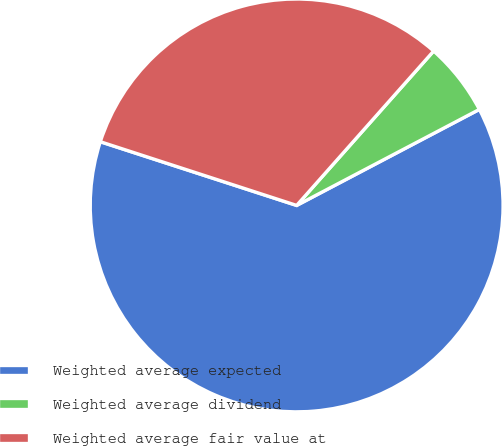<chart> <loc_0><loc_0><loc_500><loc_500><pie_chart><fcel>Weighted average expected<fcel>Weighted average dividend<fcel>Weighted average fair value at<nl><fcel>62.7%<fcel>5.75%<fcel>31.56%<nl></chart> 